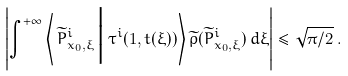<formula> <loc_0><loc_0><loc_500><loc_500>\left | \int _ { \tt } ^ { + \infty } \left \langle \, { \widetilde { P } ^ { i } _ { x _ { 0 } , \xi } } \, \Big | \, { \tau } ^ { i } ( 1 , t ( \xi ) ) \right \rangle \widetilde { \rho } ( \widetilde { P } ^ { i } _ { x _ { 0 } , \xi } ) \, d \xi \right | \leq \sqrt { \pi / 2 } \, .</formula> 